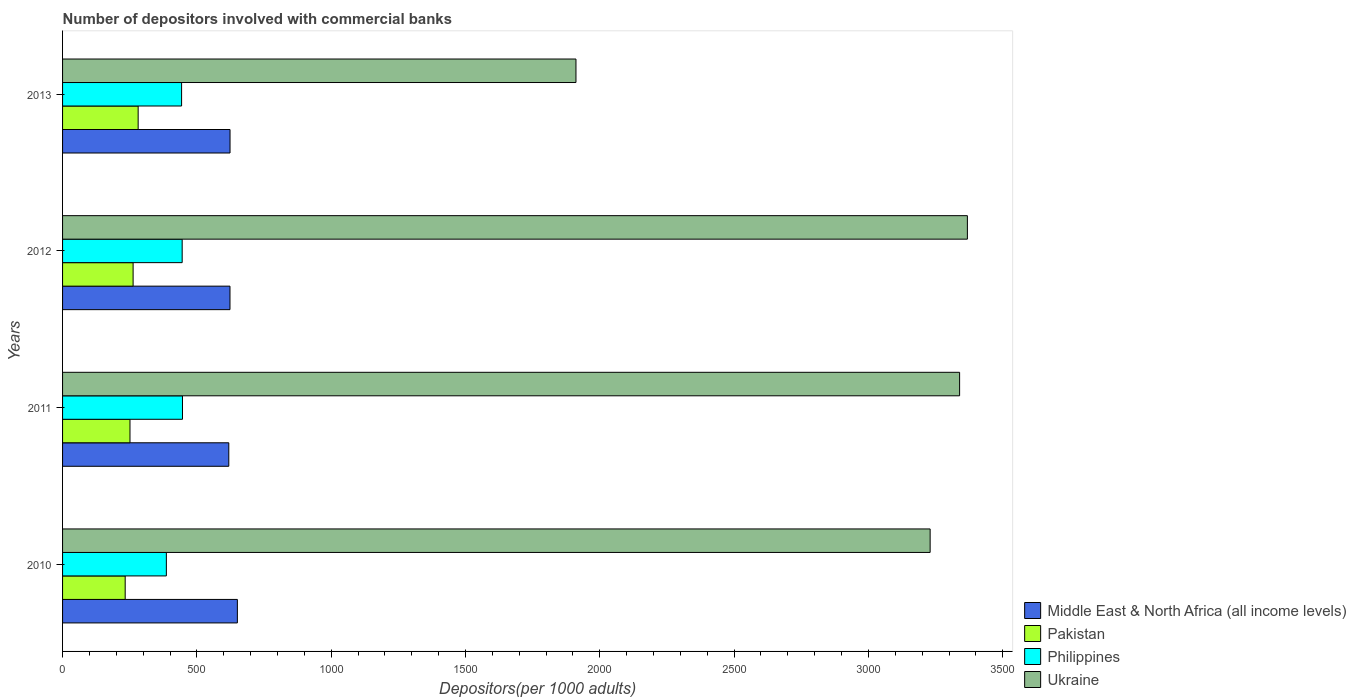How many groups of bars are there?
Give a very brief answer. 4. Are the number of bars per tick equal to the number of legend labels?
Keep it short and to the point. Yes. Are the number of bars on each tick of the Y-axis equal?
Provide a succinct answer. Yes. How many bars are there on the 1st tick from the bottom?
Ensure brevity in your answer.  4. What is the label of the 1st group of bars from the top?
Provide a short and direct response. 2013. What is the number of depositors involved with commercial banks in Middle East & North Africa (all income levels) in 2010?
Provide a succinct answer. 650.77. Across all years, what is the maximum number of depositors involved with commercial banks in Pakistan?
Your answer should be very brief. 281.38. Across all years, what is the minimum number of depositors involved with commercial banks in Pakistan?
Keep it short and to the point. 233.11. What is the total number of depositors involved with commercial banks in Pakistan in the graph?
Offer a very short reply. 1028.08. What is the difference between the number of depositors involved with commercial banks in Pakistan in 2010 and that in 2013?
Keep it short and to the point. -48.27. What is the difference between the number of depositors involved with commercial banks in Middle East & North Africa (all income levels) in 2013 and the number of depositors involved with commercial banks in Philippines in 2012?
Your answer should be compact. 178.17. What is the average number of depositors involved with commercial banks in Philippines per year?
Your answer should be compact. 430.29. In the year 2012, what is the difference between the number of depositors involved with commercial banks in Pakistan and number of depositors involved with commercial banks in Philippines?
Make the answer very short. -182.68. In how many years, is the number of depositors involved with commercial banks in Pakistan greater than 2300 ?
Your answer should be compact. 0. What is the ratio of the number of depositors involved with commercial banks in Ukraine in 2010 to that in 2012?
Provide a short and direct response. 0.96. Is the difference between the number of depositors involved with commercial banks in Pakistan in 2010 and 2013 greater than the difference between the number of depositors involved with commercial banks in Philippines in 2010 and 2013?
Offer a very short reply. Yes. What is the difference between the highest and the second highest number of depositors involved with commercial banks in Pakistan?
Your response must be concise. 18.78. What is the difference between the highest and the lowest number of depositors involved with commercial banks in Middle East & North Africa (all income levels)?
Your response must be concise. 31.92. In how many years, is the number of depositors involved with commercial banks in Ukraine greater than the average number of depositors involved with commercial banks in Ukraine taken over all years?
Offer a terse response. 3. What does the 3rd bar from the bottom in 2013 represents?
Provide a short and direct response. Philippines. Is it the case that in every year, the sum of the number of depositors involved with commercial banks in Middle East & North Africa (all income levels) and number of depositors involved with commercial banks in Ukraine is greater than the number of depositors involved with commercial banks in Philippines?
Provide a succinct answer. Yes. Are all the bars in the graph horizontal?
Keep it short and to the point. Yes. Are the values on the major ticks of X-axis written in scientific E-notation?
Ensure brevity in your answer.  No. Does the graph contain any zero values?
Ensure brevity in your answer.  No. Where does the legend appear in the graph?
Provide a short and direct response. Bottom right. What is the title of the graph?
Your answer should be compact. Number of depositors involved with commercial banks. Does "Indonesia" appear as one of the legend labels in the graph?
Offer a terse response. No. What is the label or title of the X-axis?
Provide a succinct answer. Depositors(per 1000 adults). What is the Depositors(per 1000 adults) in Middle East & North Africa (all income levels) in 2010?
Offer a very short reply. 650.77. What is the Depositors(per 1000 adults) of Pakistan in 2010?
Your answer should be compact. 233.11. What is the Depositors(per 1000 adults) in Philippines in 2010?
Your answer should be very brief. 386.38. What is the Depositors(per 1000 adults) in Ukraine in 2010?
Give a very brief answer. 3229.69. What is the Depositors(per 1000 adults) of Middle East & North Africa (all income levels) in 2011?
Make the answer very short. 618.84. What is the Depositors(per 1000 adults) in Pakistan in 2011?
Give a very brief answer. 250.99. What is the Depositors(per 1000 adults) in Philippines in 2011?
Your response must be concise. 446.4. What is the Depositors(per 1000 adults) in Ukraine in 2011?
Provide a succinct answer. 3339.41. What is the Depositors(per 1000 adults) of Middle East & North Africa (all income levels) in 2012?
Keep it short and to the point. 623.22. What is the Depositors(per 1000 adults) of Pakistan in 2012?
Your answer should be compact. 262.6. What is the Depositors(per 1000 adults) in Philippines in 2012?
Provide a succinct answer. 445.28. What is the Depositors(per 1000 adults) in Ukraine in 2012?
Make the answer very short. 3368.39. What is the Depositors(per 1000 adults) in Middle East & North Africa (all income levels) in 2013?
Your answer should be compact. 623.45. What is the Depositors(per 1000 adults) of Pakistan in 2013?
Your response must be concise. 281.38. What is the Depositors(per 1000 adults) in Philippines in 2013?
Give a very brief answer. 443.08. What is the Depositors(per 1000 adults) of Ukraine in 2013?
Your answer should be compact. 1911.24. Across all years, what is the maximum Depositors(per 1000 adults) in Middle East & North Africa (all income levels)?
Your response must be concise. 650.77. Across all years, what is the maximum Depositors(per 1000 adults) of Pakistan?
Your response must be concise. 281.38. Across all years, what is the maximum Depositors(per 1000 adults) in Philippines?
Keep it short and to the point. 446.4. Across all years, what is the maximum Depositors(per 1000 adults) of Ukraine?
Ensure brevity in your answer.  3368.39. Across all years, what is the minimum Depositors(per 1000 adults) in Middle East & North Africa (all income levels)?
Your answer should be compact. 618.84. Across all years, what is the minimum Depositors(per 1000 adults) in Pakistan?
Make the answer very short. 233.11. Across all years, what is the minimum Depositors(per 1000 adults) in Philippines?
Give a very brief answer. 386.38. Across all years, what is the minimum Depositors(per 1000 adults) of Ukraine?
Give a very brief answer. 1911.24. What is the total Depositors(per 1000 adults) of Middle East & North Africa (all income levels) in the graph?
Provide a short and direct response. 2516.28. What is the total Depositors(per 1000 adults) in Pakistan in the graph?
Your answer should be compact. 1028.08. What is the total Depositors(per 1000 adults) in Philippines in the graph?
Give a very brief answer. 1721.14. What is the total Depositors(per 1000 adults) of Ukraine in the graph?
Provide a succinct answer. 1.18e+04. What is the difference between the Depositors(per 1000 adults) of Middle East & North Africa (all income levels) in 2010 and that in 2011?
Give a very brief answer. 31.92. What is the difference between the Depositors(per 1000 adults) of Pakistan in 2010 and that in 2011?
Ensure brevity in your answer.  -17.88. What is the difference between the Depositors(per 1000 adults) in Philippines in 2010 and that in 2011?
Your answer should be very brief. -60.02. What is the difference between the Depositors(per 1000 adults) in Ukraine in 2010 and that in 2011?
Offer a terse response. -109.71. What is the difference between the Depositors(per 1000 adults) in Middle East & North Africa (all income levels) in 2010 and that in 2012?
Provide a short and direct response. 27.55. What is the difference between the Depositors(per 1000 adults) in Pakistan in 2010 and that in 2012?
Offer a terse response. -29.49. What is the difference between the Depositors(per 1000 adults) of Philippines in 2010 and that in 2012?
Your answer should be compact. -58.9. What is the difference between the Depositors(per 1000 adults) in Ukraine in 2010 and that in 2012?
Make the answer very short. -138.7. What is the difference between the Depositors(per 1000 adults) in Middle East & North Africa (all income levels) in 2010 and that in 2013?
Your response must be concise. 27.32. What is the difference between the Depositors(per 1000 adults) of Pakistan in 2010 and that in 2013?
Offer a terse response. -48.27. What is the difference between the Depositors(per 1000 adults) in Philippines in 2010 and that in 2013?
Offer a very short reply. -56.7. What is the difference between the Depositors(per 1000 adults) in Ukraine in 2010 and that in 2013?
Give a very brief answer. 1318.46. What is the difference between the Depositors(per 1000 adults) of Middle East & North Africa (all income levels) in 2011 and that in 2012?
Give a very brief answer. -4.38. What is the difference between the Depositors(per 1000 adults) in Pakistan in 2011 and that in 2012?
Offer a terse response. -11.61. What is the difference between the Depositors(per 1000 adults) of Philippines in 2011 and that in 2012?
Your answer should be compact. 1.12. What is the difference between the Depositors(per 1000 adults) in Ukraine in 2011 and that in 2012?
Your answer should be very brief. -28.98. What is the difference between the Depositors(per 1000 adults) in Middle East & North Africa (all income levels) in 2011 and that in 2013?
Make the answer very short. -4.61. What is the difference between the Depositors(per 1000 adults) in Pakistan in 2011 and that in 2013?
Your response must be concise. -30.39. What is the difference between the Depositors(per 1000 adults) of Philippines in 2011 and that in 2013?
Ensure brevity in your answer.  3.32. What is the difference between the Depositors(per 1000 adults) of Ukraine in 2011 and that in 2013?
Your answer should be compact. 1428.17. What is the difference between the Depositors(per 1000 adults) in Middle East & North Africa (all income levels) in 2012 and that in 2013?
Your response must be concise. -0.23. What is the difference between the Depositors(per 1000 adults) in Pakistan in 2012 and that in 2013?
Offer a terse response. -18.78. What is the difference between the Depositors(per 1000 adults) of Philippines in 2012 and that in 2013?
Offer a terse response. 2.2. What is the difference between the Depositors(per 1000 adults) in Ukraine in 2012 and that in 2013?
Keep it short and to the point. 1457.15. What is the difference between the Depositors(per 1000 adults) in Middle East & North Africa (all income levels) in 2010 and the Depositors(per 1000 adults) in Pakistan in 2011?
Ensure brevity in your answer.  399.77. What is the difference between the Depositors(per 1000 adults) of Middle East & North Africa (all income levels) in 2010 and the Depositors(per 1000 adults) of Philippines in 2011?
Your response must be concise. 204.37. What is the difference between the Depositors(per 1000 adults) of Middle East & North Africa (all income levels) in 2010 and the Depositors(per 1000 adults) of Ukraine in 2011?
Offer a very short reply. -2688.64. What is the difference between the Depositors(per 1000 adults) in Pakistan in 2010 and the Depositors(per 1000 adults) in Philippines in 2011?
Offer a very short reply. -213.29. What is the difference between the Depositors(per 1000 adults) of Pakistan in 2010 and the Depositors(per 1000 adults) of Ukraine in 2011?
Your response must be concise. -3106.3. What is the difference between the Depositors(per 1000 adults) of Philippines in 2010 and the Depositors(per 1000 adults) of Ukraine in 2011?
Provide a succinct answer. -2953.02. What is the difference between the Depositors(per 1000 adults) in Middle East & North Africa (all income levels) in 2010 and the Depositors(per 1000 adults) in Pakistan in 2012?
Your answer should be compact. 388.17. What is the difference between the Depositors(per 1000 adults) in Middle East & North Africa (all income levels) in 2010 and the Depositors(per 1000 adults) in Philippines in 2012?
Your answer should be compact. 205.49. What is the difference between the Depositors(per 1000 adults) of Middle East & North Africa (all income levels) in 2010 and the Depositors(per 1000 adults) of Ukraine in 2012?
Your answer should be very brief. -2717.62. What is the difference between the Depositors(per 1000 adults) in Pakistan in 2010 and the Depositors(per 1000 adults) in Philippines in 2012?
Ensure brevity in your answer.  -212.17. What is the difference between the Depositors(per 1000 adults) of Pakistan in 2010 and the Depositors(per 1000 adults) of Ukraine in 2012?
Your answer should be compact. -3135.28. What is the difference between the Depositors(per 1000 adults) in Philippines in 2010 and the Depositors(per 1000 adults) in Ukraine in 2012?
Your answer should be compact. -2982.01. What is the difference between the Depositors(per 1000 adults) in Middle East & North Africa (all income levels) in 2010 and the Depositors(per 1000 adults) in Pakistan in 2013?
Provide a succinct answer. 369.39. What is the difference between the Depositors(per 1000 adults) in Middle East & North Africa (all income levels) in 2010 and the Depositors(per 1000 adults) in Philippines in 2013?
Offer a very short reply. 207.68. What is the difference between the Depositors(per 1000 adults) of Middle East & North Africa (all income levels) in 2010 and the Depositors(per 1000 adults) of Ukraine in 2013?
Offer a terse response. -1260.47. What is the difference between the Depositors(per 1000 adults) in Pakistan in 2010 and the Depositors(per 1000 adults) in Philippines in 2013?
Your answer should be compact. -209.97. What is the difference between the Depositors(per 1000 adults) in Pakistan in 2010 and the Depositors(per 1000 adults) in Ukraine in 2013?
Your answer should be compact. -1678.13. What is the difference between the Depositors(per 1000 adults) of Philippines in 2010 and the Depositors(per 1000 adults) of Ukraine in 2013?
Your answer should be very brief. -1524.85. What is the difference between the Depositors(per 1000 adults) in Middle East & North Africa (all income levels) in 2011 and the Depositors(per 1000 adults) in Pakistan in 2012?
Offer a terse response. 356.24. What is the difference between the Depositors(per 1000 adults) of Middle East & North Africa (all income levels) in 2011 and the Depositors(per 1000 adults) of Philippines in 2012?
Offer a very short reply. 173.56. What is the difference between the Depositors(per 1000 adults) of Middle East & North Africa (all income levels) in 2011 and the Depositors(per 1000 adults) of Ukraine in 2012?
Give a very brief answer. -2749.55. What is the difference between the Depositors(per 1000 adults) in Pakistan in 2011 and the Depositors(per 1000 adults) in Philippines in 2012?
Provide a succinct answer. -194.29. What is the difference between the Depositors(per 1000 adults) of Pakistan in 2011 and the Depositors(per 1000 adults) of Ukraine in 2012?
Make the answer very short. -3117.39. What is the difference between the Depositors(per 1000 adults) in Philippines in 2011 and the Depositors(per 1000 adults) in Ukraine in 2012?
Give a very brief answer. -2921.99. What is the difference between the Depositors(per 1000 adults) in Middle East & North Africa (all income levels) in 2011 and the Depositors(per 1000 adults) in Pakistan in 2013?
Make the answer very short. 337.46. What is the difference between the Depositors(per 1000 adults) of Middle East & North Africa (all income levels) in 2011 and the Depositors(per 1000 adults) of Philippines in 2013?
Your response must be concise. 175.76. What is the difference between the Depositors(per 1000 adults) in Middle East & North Africa (all income levels) in 2011 and the Depositors(per 1000 adults) in Ukraine in 2013?
Ensure brevity in your answer.  -1292.39. What is the difference between the Depositors(per 1000 adults) of Pakistan in 2011 and the Depositors(per 1000 adults) of Philippines in 2013?
Offer a terse response. -192.09. What is the difference between the Depositors(per 1000 adults) in Pakistan in 2011 and the Depositors(per 1000 adults) in Ukraine in 2013?
Your response must be concise. -1660.24. What is the difference between the Depositors(per 1000 adults) in Philippines in 2011 and the Depositors(per 1000 adults) in Ukraine in 2013?
Provide a short and direct response. -1464.84. What is the difference between the Depositors(per 1000 adults) of Middle East & North Africa (all income levels) in 2012 and the Depositors(per 1000 adults) of Pakistan in 2013?
Your answer should be compact. 341.84. What is the difference between the Depositors(per 1000 adults) of Middle East & North Africa (all income levels) in 2012 and the Depositors(per 1000 adults) of Philippines in 2013?
Offer a very short reply. 180.14. What is the difference between the Depositors(per 1000 adults) in Middle East & North Africa (all income levels) in 2012 and the Depositors(per 1000 adults) in Ukraine in 2013?
Offer a terse response. -1288.01. What is the difference between the Depositors(per 1000 adults) in Pakistan in 2012 and the Depositors(per 1000 adults) in Philippines in 2013?
Provide a succinct answer. -180.48. What is the difference between the Depositors(per 1000 adults) of Pakistan in 2012 and the Depositors(per 1000 adults) of Ukraine in 2013?
Offer a very short reply. -1648.64. What is the difference between the Depositors(per 1000 adults) in Philippines in 2012 and the Depositors(per 1000 adults) in Ukraine in 2013?
Make the answer very short. -1465.96. What is the average Depositors(per 1000 adults) of Middle East & North Africa (all income levels) per year?
Ensure brevity in your answer.  629.07. What is the average Depositors(per 1000 adults) in Pakistan per year?
Give a very brief answer. 257.02. What is the average Depositors(per 1000 adults) of Philippines per year?
Make the answer very short. 430.29. What is the average Depositors(per 1000 adults) of Ukraine per year?
Ensure brevity in your answer.  2962.18. In the year 2010, what is the difference between the Depositors(per 1000 adults) of Middle East & North Africa (all income levels) and Depositors(per 1000 adults) of Pakistan?
Your answer should be very brief. 417.66. In the year 2010, what is the difference between the Depositors(per 1000 adults) in Middle East & North Africa (all income levels) and Depositors(per 1000 adults) in Philippines?
Provide a short and direct response. 264.38. In the year 2010, what is the difference between the Depositors(per 1000 adults) in Middle East & North Africa (all income levels) and Depositors(per 1000 adults) in Ukraine?
Offer a very short reply. -2578.93. In the year 2010, what is the difference between the Depositors(per 1000 adults) in Pakistan and Depositors(per 1000 adults) in Philippines?
Your answer should be very brief. -153.27. In the year 2010, what is the difference between the Depositors(per 1000 adults) of Pakistan and Depositors(per 1000 adults) of Ukraine?
Ensure brevity in your answer.  -2996.58. In the year 2010, what is the difference between the Depositors(per 1000 adults) in Philippines and Depositors(per 1000 adults) in Ukraine?
Offer a very short reply. -2843.31. In the year 2011, what is the difference between the Depositors(per 1000 adults) in Middle East & North Africa (all income levels) and Depositors(per 1000 adults) in Pakistan?
Your response must be concise. 367.85. In the year 2011, what is the difference between the Depositors(per 1000 adults) in Middle East & North Africa (all income levels) and Depositors(per 1000 adults) in Philippines?
Your answer should be compact. 172.44. In the year 2011, what is the difference between the Depositors(per 1000 adults) in Middle East & North Africa (all income levels) and Depositors(per 1000 adults) in Ukraine?
Your answer should be very brief. -2720.56. In the year 2011, what is the difference between the Depositors(per 1000 adults) in Pakistan and Depositors(per 1000 adults) in Philippines?
Give a very brief answer. -195.41. In the year 2011, what is the difference between the Depositors(per 1000 adults) of Pakistan and Depositors(per 1000 adults) of Ukraine?
Your answer should be very brief. -3088.41. In the year 2011, what is the difference between the Depositors(per 1000 adults) in Philippines and Depositors(per 1000 adults) in Ukraine?
Your answer should be very brief. -2893.01. In the year 2012, what is the difference between the Depositors(per 1000 adults) in Middle East & North Africa (all income levels) and Depositors(per 1000 adults) in Pakistan?
Give a very brief answer. 360.62. In the year 2012, what is the difference between the Depositors(per 1000 adults) in Middle East & North Africa (all income levels) and Depositors(per 1000 adults) in Philippines?
Offer a terse response. 177.94. In the year 2012, what is the difference between the Depositors(per 1000 adults) in Middle East & North Africa (all income levels) and Depositors(per 1000 adults) in Ukraine?
Keep it short and to the point. -2745.17. In the year 2012, what is the difference between the Depositors(per 1000 adults) of Pakistan and Depositors(per 1000 adults) of Philippines?
Ensure brevity in your answer.  -182.68. In the year 2012, what is the difference between the Depositors(per 1000 adults) in Pakistan and Depositors(per 1000 adults) in Ukraine?
Give a very brief answer. -3105.79. In the year 2012, what is the difference between the Depositors(per 1000 adults) in Philippines and Depositors(per 1000 adults) in Ukraine?
Offer a very short reply. -2923.11. In the year 2013, what is the difference between the Depositors(per 1000 adults) in Middle East & North Africa (all income levels) and Depositors(per 1000 adults) in Pakistan?
Your answer should be very brief. 342.07. In the year 2013, what is the difference between the Depositors(per 1000 adults) in Middle East & North Africa (all income levels) and Depositors(per 1000 adults) in Philippines?
Your response must be concise. 180.36. In the year 2013, what is the difference between the Depositors(per 1000 adults) of Middle East & North Africa (all income levels) and Depositors(per 1000 adults) of Ukraine?
Ensure brevity in your answer.  -1287.79. In the year 2013, what is the difference between the Depositors(per 1000 adults) of Pakistan and Depositors(per 1000 adults) of Philippines?
Keep it short and to the point. -161.7. In the year 2013, what is the difference between the Depositors(per 1000 adults) of Pakistan and Depositors(per 1000 adults) of Ukraine?
Offer a very short reply. -1629.85. In the year 2013, what is the difference between the Depositors(per 1000 adults) of Philippines and Depositors(per 1000 adults) of Ukraine?
Ensure brevity in your answer.  -1468.15. What is the ratio of the Depositors(per 1000 adults) in Middle East & North Africa (all income levels) in 2010 to that in 2011?
Your answer should be compact. 1.05. What is the ratio of the Depositors(per 1000 adults) in Pakistan in 2010 to that in 2011?
Offer a very short reply. 0.93. What is the ratio of the Depositors(per 1000 adults) in Philippines in 2010 to that in 2011?
Make the answer very short. 0.87. What is the ratio of the Depositors(per 1000 adults) in Ukraine in 2010 to that in 2011?
Provide a short and direct response. 0.97. What is the ratio of the Depositors(per 1000 adults) of Middle East & North Africa (all income levels) in 2010 to that in 2012?
Your answer should be compact. 1.04. What is the ratio of the Depositors(per 1000 adults) in Pakistan in 2010 to that in 2012?
Give a very brief answer. 0.89. What is the ratio of the Depositors(per 1000 adults) of Philippines in 2010 to that in 2012?
Your answer should be compact. 0.87. What is the ratio of the Depositors(per 1000 adults) of Ukraine in 2010 to that in 2012?
Provide a succinct answer. 0.96. What is the ratio of the Depositors(per 1000 adults) in Middle East & North Africa (all income levels) in 2010 to that in 2013?
Provide a succinct answer. 1.04. What is the ratio of the Depositors(per 1000 adults) of Pakistan in 2010 to that in 2013?
Provide a succinct answer. 0.83. What is the ratio of the Depositors(per 1000 adults) of Philippines in 2010 to that in 2013?
Your answer should be compact. 0.87. What is the ratio of the Depositors(per 1000 adults) in Ukraine in 2010 to that in 2013?
Offer a terse response. 1.69. What is the ratio of the Depositors(per 1000 adults) of Middle East & North Africa (all income levels) in 2011 to that in 2012?
Give a very brief answer. 0.99. What is the ratio of the Depositors(per 1000 adults) in Pakistan in 2011 to that in 2012?
Give a very brief answer. 0.96. What is the ratio of the Depositors(per 1000 adults) in Ukraine in 2011 to that in 2012?
Offer a very short reply. 0.99. What is the ratio of the Depositors(per 1000 adults) in Pakistan in 2011 to that in 2013?
Keep it short and to the point. 0.89. What is the ratio of the Depositors(per 1000 adults) of Philippines in 2011 to that in 2013?
Provide a short and direct response. 1.01. What is the ratio of the Depositors(per 1000 adults) of Ukraine in 2011 to that in 2013?
Your answer should be compact. 1.75. What is the ratio of the Depositors(per 1000 adults) of Philippines in 2012 to that in 2013?
Your response must be concise. 1. What is the ratio of the Depositors(per 1000 adults) in Ukraine in 2012 to that in 2013?
Your answer should be compact. 1.76. What is the difference between the highest and the second highest Depositors(per 1000 adults) in Middle East & North Africa (all income levels)?
Provide a succinct answer. 27.32. What is the difference between the highest and the second highest Depositors(per 1000 adults) of Pakistan?
Ensure brevity in your answer.  18.78. What is the difference between the highest and the second highest Depositors(per 1000 adults) of Philippines?
Your response must be concise. 1.12. What is the difference between the highest and the second highest Depositors(per 1000 adults) in Ukraine?
Give a very brief answer. 28.98. What is the difference between the highest and the lowest Depositors(per 1000 adults) in Middle East & North Africa (all income levels)?
Keep it short and to the point. 31.92. What is the difference between the highest and the lowest Depositors(per 1000 adults) in Pakistan?
Provide a succinct answer. 48.27. What is the difference between the highest and the lowest Depositors(per 1000 adults) in Philippines?
Offer a very short reply. 60.02. What is the difference between the highest and the lowest Depositors(per 1000 adults) of Ukraine?
Your answer should be compact. 1457.15. 